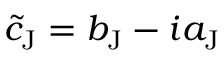<formula> <loc_0><loc_0><loc_500><loc_500>\tilde { c } _ { J } = b _ { J } - i a _ { J }</formula> 